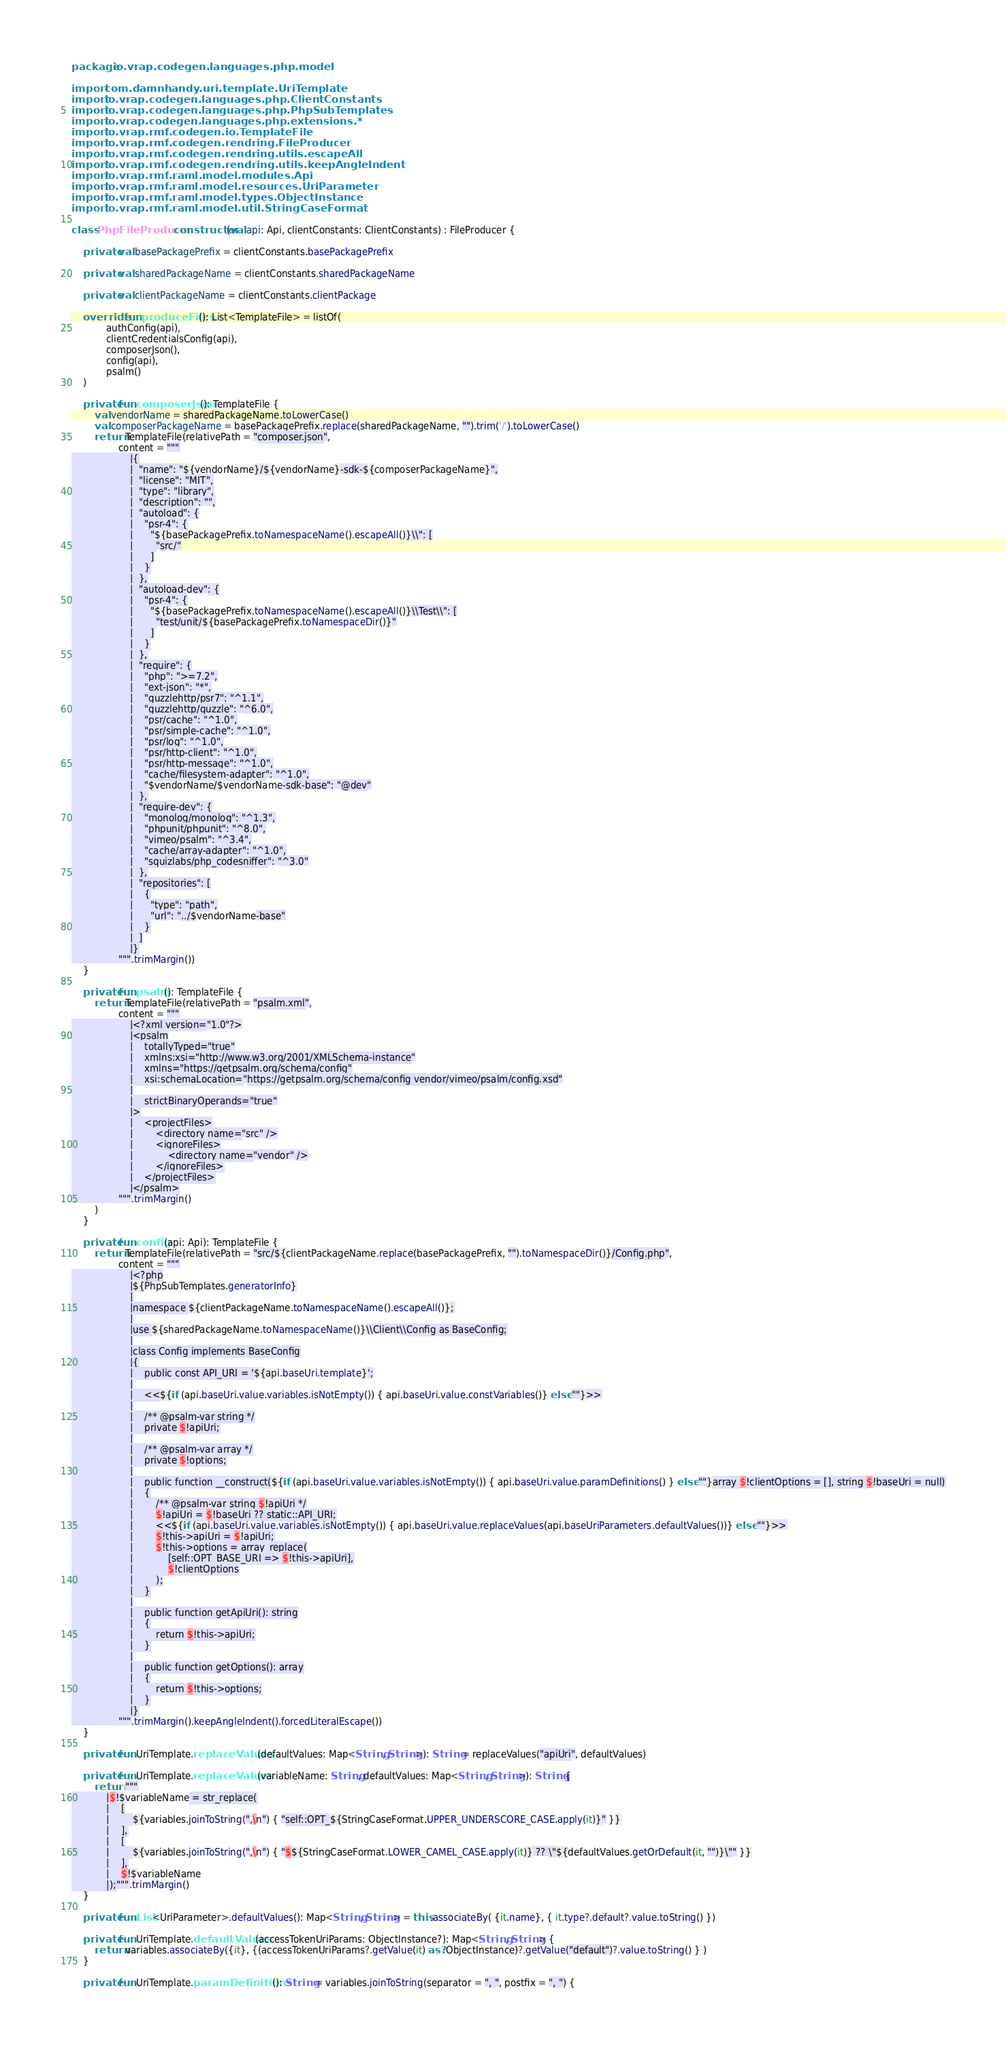<code> <loc_0><loc_0><loc_500><loc_500><_Kotlin_>package io.vrap.codegen.languages.php.model

import com.damnhandy.uri.template.UriTemplate
import io.vrap.codegen.languages.php.ClientConstants
import io.vrap.codegen.languages.php.PhpSubTemplates
import io.vrap.codegen.languages.php.extensions.*
import io.vrap.rmf.codegen.io.TemplateFile
import io.vrap.rmf.codegen.rendring.FileProducer
import io.vrap.rmf.codegen.rendring.utils.escapeAll
import io.vrap.rmf.codegen.rendring.utils.keepAngleIndent
import io.vrap.rmf.raml.model.modules.Api
import io.vrap.rmf.raml.model.resources.UriParameter
import io.vrap.rmf.raml.model.types.ObjectInstance
import io.vrap.rmf.raml.model.util.StringCaseFormat

class PhpFileProducer constructor(val api: Api, clientConstants: ClientConstants) : FileProducer {

    private val basePackagePrefix = clientConstants.basePackagePrefix

    private val sharedPackageName = clientConstants.sharedPackageName

    private val clientPackageName = clientConstants.clientPackage

    override fun produceFiles(): List<TemplateFile> = listOf(
            authConfig(api),
            clientCredentialsConfig(api),
            composerJson(),
            config(api),
            psalm()
    )

    private fun composerJson(): TemplateFile {
        val vendorName = sharedPackageName.toLowerCase()
        val composerPackageName = basePackagePrefix.replace(sharedPackageName, "").trim('/').toLowerCase()
        return TemplateFile(relativePath = "composer.json",
                content = """
                    |{
                    |  "name": "${vendorName}/${vendorName}-sdk-${composerPackageName}",
                    |  "license": "MIT",
                    |  "type": "library",
                    |  "description": "",
                    |  "autoload": {
                    |    "psr-4": {
                    |      "${basePackagePrefix.toNamespaceName().escapeAll()}\\": [
                    |        "src/"
                    |      ]
                    |    }
                    |  },
                    |  "autoload-dev": {
                    |    "psr-4": {
                    |      "${basePackagePrefix.toNamespaceName().escapeAll()}\\Test\\": [
                    |        "test/unit/${basePackagePrefix.toNamespaceDir()}"
                    |      ]
                    |    }
                    |  },
                    |  "require": {
                    |    "php": ">=7.2",
                    |    "ext-json": "*",
                    |    "guzzlehttp/psr7": "^1.1",
                    |    "guzzlehttp/guzzle": "^6.0",
                    |    "psr/cache": "^1.0",
                    |    "psr/simple-cache": "^1.0",
                    |    "psr/log": "^1.0",
                    |    "psr/http-client": "^1.0",
                    |    "psr/http-message": "^1.0",
                    |    "cache/filesystem-adapter": "^1.0",
                    |    "$vendorName/$vendorName-sdk-base": "@dev"
                    |  },
                    |  "require-dev": {
                    |    "monolog/monolog": "^1.3",
                    |    "phpunit/phpunit": "^8.0",
                    |    "vimeo/psalm": "^3.4",
                    |    "cache/array-adapter": "^1.0",
                    |    "squizlabs/php_codesniffer": "^3.0"
                    |  },
                    |  "repositories": [
                    |    {
                    |      "type": "path",
                    |      "url": "../$vendorName-base"
                    |    }
                    |  ]
                    |}
                """.trimMargin())
    }

    private fun psalm(): TemplateFile {
        return TemplateFile(relativePath = "psalm.xml",
                content = """
                    |<?xml version="1.0"?>
                    |<psalm
                    |    totallyTyped="true"
                    |    xmlns:xsi="http://www.w3.org/2001/XMLSchema-instance"
                    |    xmlns="https://getpsalm.org/schema/config"
                    |    xsi:schemaLocation="https://getpsalm.org/schema/config vendor/vimeo/psalm/config.xsd"
                    |
                    |    strictBinaryOperands="true"
                    |>
                    |    <projectFiles>
                    |        <directory name="src" />
                    |        <ignoreFiles>
                    |            <directory name="vendor" />
                    |        </ignoreFiles>
                    |    </projectFiles>
                    |</psalm>
                """.trimMargin()
        )
    }

    private fun config(api: Api): TemplateFile {
        return TemplateFile(relativePath = "src/${clientPackageName.replace(basePackagePrefix, "").toNamespaceDir()}/Config.php",
                content = """
                    |<?php
                    |${PhpSubTemplates.generatorInfo}
                    |
                    |namespace ${clientPackageName.toNamespaceName().escapeAll()};
                    |
                    |use ${sharedPackageName.toNamespaceName()}\\Client\\Config as BaseConfig;
                    |
                    |class Config implements BaseConfig
                    |{
                    |    public const API_URI = '${api.baseUri.template}';
                    |
                    |    <<${if (api.baseUri.value.variables.isNotEmpty()) { api.baseUri.value.constVariables()} else ""}>>
                    |
                    |    /** @psalm-var string */
                    |    private $!apiUri;
                    |
                    |    /** @psalm-var array */
                    |    private $!options;
                    |
                    |    public function __construct(${if (api.baseUri.value.variables.isNotEmpty()) { api.baseUri.value.paramDefinitions() } else ""}array $!clientOptions = [], string $!baseUri = null)
                    |    {
                    |        /** @psalm-var string $!apiUri */
                    |        $!apiUri = $!baseUri ?? static::API_URI;
                    |        <<${if (api.baseUri.value.variables.isNotEmpty()) { api.baseUri.value.replaceValues(api.baseUriParameters.defaultValues())} else ""}>>
                    |        $!this->apiUri = $!apiUri;
                    |        $!this->options = array_replace(
                    |            [self::OPT_BASE_URI => $!this->apiUri],
                    |            $!clientOptions
                    |        );
                    |    }
                    |
                    |    public function getApiUri(): string
                    |    {
                    |        return $!this->apiUri;
                    |    }
                    |
                    |    public function getOptions(): array
                    |    {
                    |        return $!this->options;
                    |    }
                    |}
                """.trimMargin().keepAngleIndent().forcedLiteralEscape())
    }

    private fun UriTemplate.replaceValues(defaultValues: Map<String, String>): String = replaceValues("apiUri", defaultValues)

    private fun UriTemplate.replaceValues(variableName: String, defaultValues: Map<String, String>): String {
        return """
            |$!$variableName = str_replace(
            |    [
            |        ${variables.joinToString(",\n") { "self::OPT_${StringCaseFormat.UPPER_UNDERSCORE_CASE.apply(it)}" }}
            |    ],
            |    [
            |        ${variables.joinToString(",\n") { "$${StringCaseFormat.LOWER_CAMEL_CASE.apply(it)} ?? \"${defaultValues.getOrDefault(it, "")}\"" }}
            |    ],
            |    $!$variableName
            |);""".trimMargin()
    }

    private fun List<UriParameter>.defaultValues(): Map<String, String> = this.associateBy( {it.name}, { it.type?.default?.value.toString() })

    private fun UriTemplate.defaultValues(accessTokenUriParams: ObjectInstance?): Map<String, String> {
        return variables.associateBy({it}, {(accessTokenUriParams?.getValue(it) as? ObjectInstance)?.getValue("default")?.value.toString() } )
    }

    private fun UriTemplate.paramDefinitions(): String = variables.joinToString(separator = ", ", postfix = ", ") {</code> 